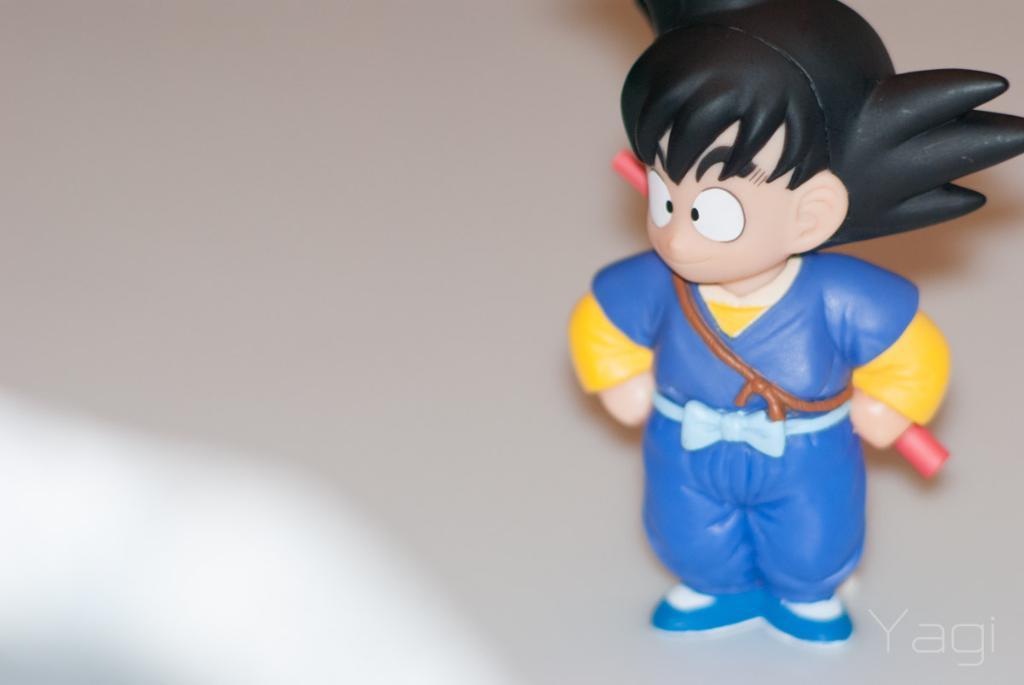In one or two sentences, can you explain what this image depicts? In this image there is a toy of a man who is holding the blue dress and holding the red colour rod which is behind him. 